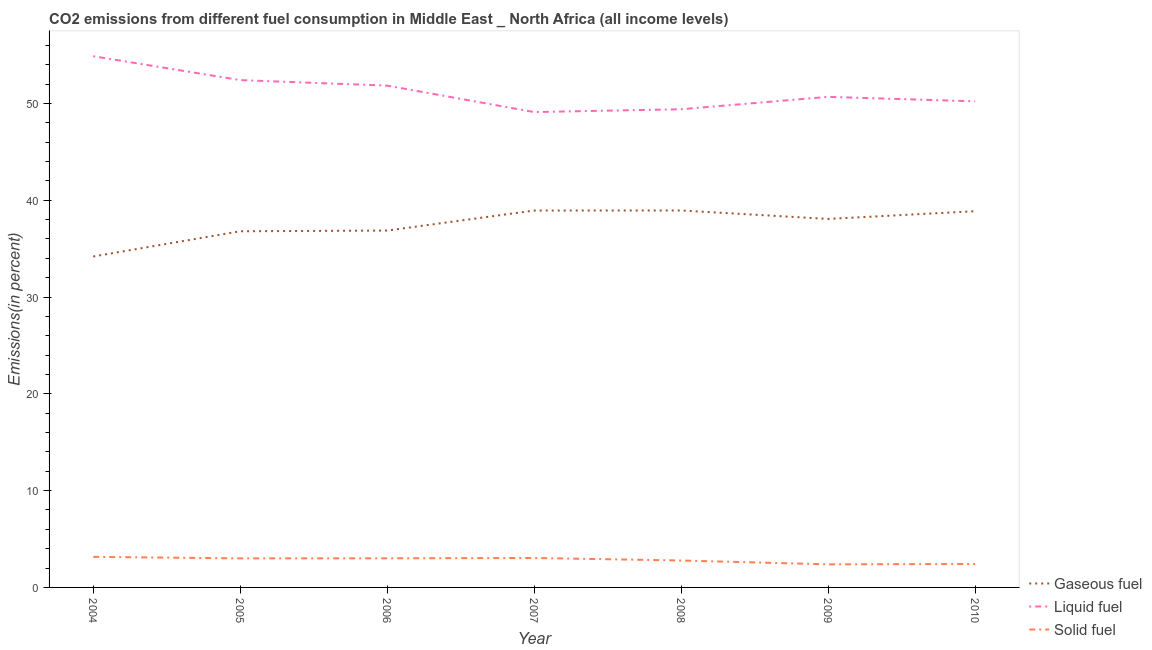What is the percentage of liquid fuel emission in 2008?
Give a very brief answer. 49.4. Across all years, what is the maximum percentage of gaseous fuel emission?
Provide a short and direct response. 38.94. Across all years, what is the minimum percentage of liquid fuel emission?
Your answer should be very brief. 49.11. In which year was the percentage of gaseous fuel emission minimum?
Offer a very short reply. 2004. What is the total percentage of solid fuel emission in the graph?
Offer a terse response. 19.8. What is the difference between the percentage of gaseous fuel emission in 2005 and that in 2010?
Give a very brief answer. -2.07. What is the difference between the percentage of solid fuel emission in 2004 and the percentage of gaseous fuel emission in 2009?
Your answer should be very brief. -34.91. What is the average percentage of solid fuel emission per year?
Your answer should be compact. 2.83. In the year 2005, what is the difference between the percentage of solid fuel emission and percentage of liquid fuel emission?
Your answer should be compact. -49.41. What is the ratio of the percentage of solid fuel emission in 2004 to that in 2010?
Make the answer very short. 1.3. Is the percentage of solid fuel emission in 2007 less than that in 2008?
Provide a succinct answer. No. What is the difference between the highest and the second highest percentage of liquid fuel emission?
Offer a very short reply. 2.47. What is the difference between the highest and the lowest percentage of gaseous fuel emission?
Your answer should be very brief. 4.75. Is the sum of the percentage of liquid fuel emission in 2004 and 2006 greater than the maximum percentage of solid fuel emission across all years?
Offer a terse response. Yes. Is it the case that in every year, the sum of the percentage of gaseous fuel emission and percentage of liquid fuel emission is greater than the percentage of solid fuel emission?
Provide a short and direct response. Yes. How many lines are there?
Make the answer very short. 3. What is the difference between two consecutive major ticks on the Y-axis?
Your response must be concise. 10. Does the graph contain grids?
Make the answer very short. No. What is the title of the graph?
Your answer should be very brief. CO2 emissions from different fuel consumption in Middle East _ North Africa (all income levels). What is the label or title of the X-axis?
Provide a short and direct response. Year. What is the label or title of the Y-axis?
Provide a short and direct response. Emissions(in percent). What is the Emissions(in percent) in Gaseous fuel in 2004?
Give a very brief answer. 34.19. What is the Emissions(in percent) of Liquid fuel in 2004?
Give a very brief answer. 54.88. What is the Emissions(in percent) of Solid fuel in 2004?
Provide a short and direct response. 3.16. What is the Emissions(in percent) in Gaseous fuel in 2005?
Make the answer very short. 36.8. What is the Emissions(in percent) in Liquid fuel in 2005?
Your answer should be compact. 52.41. What is the Emissions(in percent) of Solid fuel in 2005?
Make the answer very short. 3. What is the Emissions(in percent) in Gaseous fuel in 2006?
Make the answer very short. 36.87. What is the Emissions(in percent) of Liquid fuel in 2006?
Ensure brevity in your answer.  51.84. What is the Emissions(in percent) of Solid fuel in 2006?
Keep it short and to the point. 3.01. What is the Emissions(in percent) of Gaseous fuel in 2007?
Your answer should be compact. 38.94. What is the Emissions(in percent) of Liquid fuel in 2007?
Your answer should be very brief. 49.11. What is the Emissions(in percent) of Solid fuel in 2007?
Keep it short and to the point. 3.04. What is the Emissions(in percent) in Gaseous fuel in 2008?
Your answer should be compact. 38.94. What is the Emissions(in percent) in Liquid fuel in 2008?
Your answer should be very brief. 49.4. What is the Emissions(in percent) of Solid fuel in 2008?
Give a very brief answer. 2.78. What is the Emissions(in percent) of Gaseous fuel in 2009?
Your answer should be very brief. 38.07. What is the Emissions(in percent) of Liquid fuel in 2009?
Keep it short and to the point. 50.68. What is the Emissions(in percent) of Solid fuel in 2009?
Provide a short and direct response. 2.38. What is the Emissions(in percent) in Gaseous fuel in 2010?
Keep it short and to the point. 38.87. What is the Emissions(in percent) in Liquid fuel in 2010?
Your answer should be compact. 50.22. What is the Emissions(in percent) in Solid fuel in 2010?
Your response must be concise. 2.42. Across all years, what is the maximum Emissions(in percent) in Gaseous fuel?
Offer a very short reply. 38.94. Across all years, what is the maximum Emissions(in percent) of Liquid fuel?
Provide a short and direct response. 54.88. Across all years, what is the maximum Emissions(in percent) of Solid fuel?
Offer a very short reply. 3.16. Across all years, what is the minimum Emissions(in percent) of Gaseous fuel?
Offer a terse response. 34.19. Across all years, what is the minimum Emissions(in percent) of Liquid fuel?
Give a very brief answer. 49.11. Across all years, what is the minimum Emissions(in percent) in Solid fuel?
Your response must be concise. 2.38. What is the total Emissions(in percent) in Gaseous fuel in the graph?
Your answer should be compact. 262.67. What is the total Emissions(in percent) of Liquid fuel in the graph?
Keep it short and to the point. 358.54. What is the total Emissions(in percent) in Solid fuel in the graph?
Make the answer very short. 19.8. What is the difference between the Emissions(in percent) of Gaseous fuel in 2004 and that in 2005?
Provide a succinct answer. -2.6. What is the difference between the Emissions(in percent) in Liquid fuel in 2004 and that in 2005?
Provide a succinct answer. 2.46. What is the difference between the Emissions(in percent) of Solid fuel in 2004 and that in 2005?
Give a very brief answer. 0.16. What is the difference between the Emissions(in percent) in Gaseous fuel in 2004 and that in 2006?
Provide a succinct answer. -2.68. What is the difference between the Emissions(in percent) in Liquid fuel in 2004 and that in 2006?
Provide a succinct answer. 3.04. What is the difference between the Emissions(in percent) of Solid fuel in 2004 and that in 2006?
Ensure brevity in your answer.  0.15. What is the difference between the Emissions(in percent) in Gaseous fuel in 2004 and that in 2007?
Keep it short and to the point. -4.74. What is the difference between the Emissions(in percent) of Liquid fuel in 2004 and that in 2007?
Your response must be concise. 5.77. What is the difference between the Emissions(in percent) of Solid fuel in 2004 and that in 2007?
Provide a short and direct response. 0.11. What is the difference between the Emissions(in percent) of Gaseous fuel in 2004 and that in 2008?
Ensure brevity in your answer.  -4.75. What is the difference between the Emissions(in percent) of Liquid fuel in 2004 and that in 2008?
Make the answer very short. 5.48. What is the difference between the Emissions(in percent) of Solid fuel in 2004 and that in 2008?
Your answer should be very brief. 0.38. What is the difference between the Emissions(in percent) in Gaseous fuel in 2004 and that in 2009?
Your response must be concise. -3.88. What is the difference between the Emissions(in percent) of Liquid fuel in 2004 and that in 2009?
Your answer should be very brief. 4.2. What is the difference between the Emissions(in percent) in Solid fuel in 2004 and that in 2009?
Make the answer very short. 0.77. What is the difference between the Emissions(in percent) in Gaseous fuel in 2004 and that in 2010?
Offer a terse response. -4.68. What is the difference between the Emissions(in percent) in Liquid fuel in 2004 and that in 2010?
Offer a terse response. 4.66. What is the difference between the Emissions(in percent) of Solid fuel in 2004 and that in 2010?
Offer a terse response. 0.74. What is the difference between the Emissions(in percent) in Gaseous fuel in 2005 and that in 2006?
Your response must be concise. -0.07. What is the difference between the Emissions(in percent) in Liquid fuel in 2005 and that in 2006?
Provide a short and direct response. 0.57. What is the difference between the Emissions(in percent) of Solid fuel in 2005 and that in 2006?
Offer a very short reply. -0.01. What is the difference between the Emissions(in percent) of Gaseous fuel in 2005 and that in 2007?
Your answer should be compact. -2.14. What is the difference between the Emissions(in percent) of Liquid fuel in 2005 and that in 2007?
Provide a succinct answer. 3.3. What is the difference between the Emissions(in percent) of Solid fuel in 2005 and that in 2007?
Your response must be concise. -0.04. What is the difference between the Emissions(in percent) of Gaseous fuel in 2005 and that in 2008?
Keep it short and to the point. -2.15. What is the difference between the Emissions(in percent) of Liquid fuel in 2005 and that in 2008?
Provide a succinct answer. 3.01. What is the difference between the Emissions(in percent) in Solid fuel in 2005 and that in 2008?
Your answer should be compact. 0.22. What is the difference between the Emissions(in percent) of Gaseous fuel in 2005 and that in 2009?
Your answer should be compact. -1.27. What is the difference between the Emissions(in percent) in Liquid fuel in 2005 and that in 2009?
Your response must be concise. 1.73. What is the difference between the Emissions(in percent) in Solid fuel in 2005 and that in 2009?
Offer a terse response. 0.62. What is the difference between the Emissions(in percent) in Gaseous fuel in 2005 and that in 2010?
Offer a very short reply. -2.07. What is the difference between the Emissions(in percent) in Liquid fuel in 2005 and that in 2010?
Ensure brevity in your answer.  2.2. What is the difference between the Emissions(in percent) in Solid fuel in 2005 and that in 2010?
Your answer should be compact. 0.58. What is the difference between the Emissions(in percent) of Gaseous fuel in 2006 and that in 2007?
Your response must be concise. -2.07. What is the difference between the Emissions(in percent) in Liquid fuel in 2006 and that in 2007?
Ensure brevity in your answer.  2.73. What is the difference between the Emissions(in percent) in Solid fuel in 2006 and that in 2007?
Your answer should be compact. -0.04. What is the difference between the Emissions(in percent) of Gaseous fuel in 2006 and that in 2008?
Give a very brief answer. -2.07. What is the difference between the Emissions(in percent) of Liquid fuel in 2006 and that in 2008?
Keep it short and to the point. 2.44. What is the difference between the Emissions(in percent) in Solid fuel in 2006 and that in 2008?
Offer a very short reply. 0.23. What is the difference between the Emissions(in percent) in Gaseous fuel in 2006 and that in 2009?
Provide a succinct answer. -1.2. What is the difference between the Emissions(in percent) in Liquid fuel in 2006 and that in 2009?
Offer a very short reply. 1.16. What is the difference between the Emissions(in percent) of Solid fuel in 2006 and that in 2009?
Your response must be concise. 0.62. What is the difference between the Emissions(in percent) of Gaseous fuel in 2006 and that in 2010?
Give a very brief answer. -2. What is the difference between the Emissions(in percent) in Liquid fuel in 2006 and that in 2010?
Offer a very short reply. 1.62. What is the difference between the Emissions(in percent) in Solid fuel in 2006 and that in 2010?
Your answer should be very brief. 0.59. What is the difference between the Emissions(in percent) in Gaseous fuel in 2007 and that in 2008?
Give a very brief answer. -0.01. What is the difference between the Emissions(in percent) of Liquid fuel in 2007 and that in 2008?
Offer a very short reply. -0.29. What is the difference between the Emissions(in percent) in Solid fuel in 2007 and that in 2008?
Your response must be concise. 0.26. What is the difference between the Emissions(in percent) in Gaseous fuel in 2007 and that in 2009?
Provide a short and direct response. 0.87. What is the difference between the Emissions(in percent) in Liquid fuel in 2007 and that in 2009?
Offer a very short reply. -1.57. What is the difference between the Emissions(in percent) of Solid fuel in 2007 and that in 2009?
Ensure brevity in your answer.  0.66. What is the difference between the Emissions(in percent) of Gaseous fuel in 2007 and that in 2010?
Your answer should be compact. 0.07. What is the difference between the Emissions(in percent) in Liquid fuel in 2007 and that in 2010?
Provide a short and direct response. -1.11. What is the difference between the Emissions(in percent) of Solid fuel in 2007 and that in 2010?
Your answer should be very brief. 0.62. What is the difference between the Emissions(in percent) of Gaseous fuel in 2008 and that in 2009?
Offer a terse response. 0.87. What is the difference between the Emissions(in percent) in Liquid fuel in 2008 and that in 2009?
Ensure brevity in your answer.  -1.28. What is the difference between the Emissions(in percent) in Solid fuel in 2008 and that in 2009?
Give a very brief answer. 0.4. What is the difference between the Emissions(in percent) in Gaseous fuel in 2008 and that in 2010?
Ensure brevity in your answer.  0.07. What is the difference between the Emissions(in percent) in Liquid fuel in 2008 and that in 2010?
Your answer should be very brief. -0.82. What is the difference between the Emissions(in percent) in Solid fuel in 2008 and that in 2010?
Offer a very short reply. 0.36. What is the difference between the Emissions(in percent) in Gaseous fuel in 2009 and that in 2010?
Offer a terse response. -0.8. What is the difference between the Emissions(in percent) in Liquid fuel in 2009 and that in 2010?
Provide a succinct answer. 0.46. What is the difference between the Emissions(in percent) in Solid fuel in 2009 and that in 2010?
Offer a terse response. -0.04. What is the difference between the Emissions(in percent) of Gaseous fuel in 2004 and the Emissions(in percent) of Liquid fuel in 2005?
Keep it short and to the point. -18.22. What is the difference between the Emissions(in percent) of Gaseous fuel in 2004 and the Emissions(in percent) of Solid fuel in 2005?
Offer a very short reply. 31.19. What is the difference between the Emissions(in percent) of Liquid fuel in 2004 and the Emissions(in percent) of Solid fuel in 2005?
Keep it short and to the point. 51.88. What is the difference between the Emissions(in percent) in Gaseous fuel in 2004 and the Emissions(in percent) in Liquid fuel in 2006?
Your answer should be compact. -17.65. What is the difference between the Emissions(in percent) in Gaseous fuel in 2004 and the Emissions(in percent) in Solid fuel in 2006?
Give a very brief answer. 31.18. What is the difference between the Emissions(in percent) in Liquid fuel in 2004 and the Emissions(in percent) in Solid fuel in 2006?
Your response must be concise. 51.87. What is the difference between the Emissions(in percent) of Gaseous fuel in 2004 and the Emissions(in percent) of Liquid fuel in 2007?
Ensure brevity in your answer.  -14.92. What is the difference between the Emissions(in percent) in Gaseous fuel in 2004 and the Emissions(in percent) in Solid fuel in 2007?
Offer a terse response. 31.15. What is the difference between the Emissions(in percent) of Liquid fuel in 2004 and the Emissions(in percent) of Solid fuel in 2007?
Offer a very short reply. 51.83. What is the difference between the Emissions(in percent) of Gaseous fuel in 2004 and the Emissions(in percent) of Liquid fuel in 2008?
Offer a very short reply. -15.21. What is the difference between the Emissions(in percent) in Gaseous fuel in 2004 and the Emissions(in percent) in Solid fuel in 2008?
Keep it short and to the point. 31.41. What is the difference between the Emissions(in percent) in Liquid fuel in 2004 and the Emissions(in percent) in Solid fuel in 2008?
Ensure brevity in your answer.  52.1. What is the difference between the Emissions(in percent) of Gaseous fuel in 2004 and the Emissions(in percent) of Liquid fuel in 2009?
Provide a succinct answer. -16.49. What is the difference between the Emissions(in percent) of Gaseous fuel in 2004 and the Emissions(in percent) of Solid fuel in 2009?
Your answer should be very brief. 31.81. What is the difference between the Emissions(in percent) in Liquid fuel in 2004 and the Emissions(in percent) in Solid fuel in 2009?
Your answer should be very brief. 52.49. What is the difference between the Emissions(in percent) in Gaseous fuel in 2004 and the Emissions(in percent) in Liquid fuel in 2010?
Make the answer very short. -16.03. What is the difference between the Emissions(in percent) in Gaseous fuel in 2004 and the Emissions(in percent) in Solid fuel in 2010?
Offer a terse response. 31.77. What is the difference between the Emissions(in percent) of Liquid fuel in 2004 and the Emissions(in percent) of Solid fuel in 2010?
Offer a terse response. 52.46. What is the difference between the Emissions(in percent) of Gaseous fuel in 2005 and the Emissions(in percent) of Liquid fuel in 2006?
Offer a terse response. -15.04. What is the difference between the Emissions(in percent) in Gaseous fuel in 2005 and the Emissions(in percent) in Solid fuel in 2006?
Make the answer very short. 33.79. What is the difference between the Emissions(in percent) of Liquid fuel in 2005 and the Emissions(in percent) of Solid fuel in 2006?
Your answer should be compact. 49.4. What is the difference between the Emissions(in percent) of Gaseous fuel in 2005 and the Emissions(in percent) of Liquid fuel in 2007?
Provide a succinct answer. -12.31. What is the difference between the Emissions(in percent) of Gaseous fuel in 2005 and the Emissions(in percent) of Solid fuel in 2007?
Your response must be concise. 33.75. What is the difference between the Emissions(in percent) of Liquid fuel in 2005 and the Emissions(in percent) of Solid fuel in 2007?
Ensure brevity in your answer.  49.37. What is the difference between the Emissions(in percent) in Gaseous fuel in 2005 and the Emissions(in percent) in Liquid fuel in 2008?
Your answer should be compact. -12.6. What is the difference between the Emissions(in percent) of Gaseous fuel in 2005 and the Emissions(in percent) of Solid fuel in 2008?
Your answer should be very brief. 34.01. What is the difference between the Emissions(in percent) in Liquid fuel in 2005 and the Emissions(in percent) in Solid fuel in 2008?
Give a very brief answer. 49.63. What is the difference between the Emissions(in percent) in Gaseous fuel in 2005 and the Emissions(in percent) in Liquid fuel in 2009?
Your response must be concise. -13.89. What is the difference between the Emissions(in percent) in Gaseous fuel in 2005 and the Emissions(in percent) in Solid fuel in 2009?
Offer a terse response. 34.41. What is the difference between the Emissions(in percent) of Liquid fuel in 2005 and the Emissions(in percent) of Solid fuel in 2009?
Offer a very short reply. 50.03. What is the difference between the Emissions(in percent) of Gaseous fuel in 2005 and the Emissions(in percent) of Liquid fuel in 2010?
Ensure brevity in your answer.  -13.42. What is the difference between the Emissions(in percent) of Gaseous fuel in 2005 and the Emissions(in percent) of Solid fuel in 2010?
Your answer should be very brief. 34.37. What is the difference between the Emissions(in percent) in Liquid fuel in 2005 and the Emissions(in percent) in Solid fuel in 2010?
Your answer should be compact. 49.99. What is the difference between the Emissions(in percent) in Gaseous fuel in 2006 and the Emissions(in percent) in Liquid fuel in 2007?
Provide a succinct answer. -12.24. What is the difference between the Emissions(in percent) in Gaseous fuel in 2006 and the Emissions(in percent) in Solid fuel in 2007?
Your response must be concise. 33.82. What is the difference between the Emissions(in percent) in Liquid fuel in 2006 and the Emissions(in percent) in Solid fuel in 2007?
Ensure brevity in your answer.  48.8. What is the difference between the Emissions(in percent) of Gaseous fuel in 2006 and the Emissions(in percent) of Liquid fuel in 2008?
Ensure brevity in your answer.  -12.53. What is the difference between the Emissions(in percent) in Gaseous fuel in 2006 and the Emissions(in percent) in Solid fuel in 2008?
Your response must be concise. 34.09. What is the difference between the Emissions(in percent) in Liquid fuel in 2006 and the Emissions(in percent) in Solid fuel in 2008?
Your answer should be very brief. 49.06. What is the difference between the Emissions(in percent) of Gaseous fuel in 2006 and the Emissions(in percent) of Liquid fuel in 2009?
Offer a very short reply. -13.81. What is the difference between the Emissions(in percent) in Gaseous fuel in 2006 and the Emissions(in percent) in Solid fuel in 2009?
Offer a terse response. 34.48. What is the difference between the Emissions(in percent) of Liquid fuel in 2006 and the Emissions(in percent) of Solid fuel in 2009?
Make the answer very short. 49.46. What is the difference between the Emissions(in percent) of Gaseous fuel in 2006 and the Emissions(in percent) of Liquid fuel in 2010?
Your answer should be very brief. -13.35. What is the difference between the Emissions(in percent) in Gaseous fuel in 2006 and the Emissions(in percent) in Solid fuel in 2010?
Your response must be concise. 34.45. What is the difference between the Emissions(in percent) in Liquid fuel in 2006 and the Emissions(in percent) in Solid fuel in 2010?
Offer a very short reply. 49.42. What is the difference between the Emissions(in percent) of Gaseous fuel in 2007 and the Emissions(in percent) of Liquid fuel in 2008?
Provide a succinct answer. -10.46. What is the difference between the Emissions(in percent) in Gaseous fuel in 2007 and the Emissions(in percent) in Solid fuel in 2008?
Your answer should be compact. 36.15. What is the difference between the Emissions(in percent) of Liquid fuel in 2007 and the Emissions(in percent) of Solid fuel in 2008?
Keep it short and to the point. 46.33. What is the difference between the Emissions(in percent) in Gaseous fuel in 2007 and the Emissions(in percent) in Liquid fuel in 2009?
Your answer should be compact. -11.75. What is the difference between the Emissions(in percent) of Gaseous fuel in 2007 and the Emissions(in percent) of Solid fuel in 2009?
Provide a short and direct response. 36.55. What is the difference between the Emissions(in percent) in Liquid fuel in 2007 and the Emissions(in percent) in Solid fuel in 2009?
Offer a very short reply. 46.73. What is the difference between the Emissions(in percent) in Gaseous fuel in 2007 and the Emissions(in percent) in Liquid fuel in 2010?
Your response must be concise. -11.28. What is the difference between the Emissions(in percent) in Gaseous fuel in 2007 and the Emissions(in percent) in Solid fuel in 2010?
Make the answer very short. 36.51. What is the difference between the Emissions(in percent) in Liquid fuel in 2007 and the Emissions(in percent) in Solid fuel in 2010?
Offer a terse response. 46.69. What is the difference between the Emissions(in percent) in Gaseous fuel in 2008 and the Emissions(in percent) in Liquid fuel in 2009?
Provide a succinct answer. -11.74. What is the difference between the Emissions(in percent) of Gaseous fuel in 2008 and the Emissions(in percent) of Solid fuel in 2009?
Keep it short and to the point. 36.56. What is the difference between the Emissions(in percent) in Liquid fuel in 2008 and the Emissions(in percent) in Solid fuel in 2009?
Provide a succinct answer. 47.02. What is the difference between the Emissions(in percent) in Gaseous fuel in 2008 and the Emissions(in percent) in Liquid fuel in 2010?
Your answer should be very brief. -11.28. What is the difference between the Emissions(in percent) of Gaseous fuel in 2008 and the Emissions(in percent) of Solid fuel in 2010?
Provide a succinct answer. 36.52. What is the difference between the Emissions(in percent) in Liquid fuel in 2008 and the Emissions(in percent) in Solid fuel in 2010?
Your answer should be very brief. 46.98. What is the difference between the Emissions(in percent) in Gaseous fuel in 2009 and the Emissions(in percent) in Liquid fuel in 2010?
Keep it short and to the point. -12.15. What is the difference between the Emissions(in percent) of Gaseous fuel in 2009 and the Emissions(in percent) of Solid fuel in 2010?
Your answer should be compact. 35.65. What is the difference between the Emissions(in percent) of Liquid fuel in 2009 and the Emissions(in percent) of Solid fuel in 2010?
Offer a very short reply. 48.26. What is the average Emissions(in percent) in Gaseous fuel per year?
Your response must be concise. 37.52. What is the average Emissions(in percent) in Liquid fuel per year?
Provide a short and direct response. 51.22. What is the average Emissions(in percent) in Solid fuel per year?
Provide a short and direct response. 2.83. In the year 2004, what is the difference between the Emissions(in percent) of Gaseous fuel and Emissions(in percent) of Liquid fuel?
Offer a very short reply. -20.69. In the year 2004, what is the difference between the Emissions(in percent) in Gaseous fuel and Emissions(in percent) in Solid fuel?
Your answer should be very brief. 31.03. In the year 2004, what is the difference between the Emissions(in percent) of Liquid fuel and Emissions(in percent) of Solid fuel?
Offer a terse response. 51.72. In the year 2005, what is the difference between the Emissions(in percent) in Gaseous fuel and Emissions(in percent) in Liquid fuel?
Your answer should be very brief. -15.62. In the year 2005, what is the difference between the Emissions(in percent) of Gaseous fuel and Emissions(in percent) of Solid fuel?
Give a very brief answer. 33.8. In the year 2005, what is the difference between the Emissions(in percent) of Liquid fuel and Emissions(in percent) of Solid fuel?
Your response must be concise. 49.41. In the year 2006, what is the difference between the Emissions(in percent) of Gaseous fuel and Emissions(in percent) of Liquid fuel?
Your answer should be very brief. -14.97. In the year 2006, what is the difference between the Emissions(in percent) in Gaseous fuel and Emissions(in percent) in Solid fuel?
Your response must be concise. 33.86. In the year 2006, what is the difference between the Emissions(in percent) of Liquid fuel and Emissions(in percent) of Solid fuel?
Give a very brief answer. 48.83. In the year 2007, what is the difference between the Emissions(in percent) of Gaseous fuel and Emissions(in percent) of Liquid fuel?
Make the answer very short. -10.17. In the year 2007, what is the difference between the Emissions(in percent) in Gaseous fuel and Emissions(in percent) in Solid fuel?
Keep it short and to the point. 35.89. In the year 2007, what is the difference between the Emissions(in percent) in Liquid fuel and Emissions(in percent) in Solid fuel?
Your answer should be very brief. 46.07. In the year 2008, what is the difference between the Emissions(in percent) in Gaseous fuel and Emissions(in percent) in Liquid fuel?
Make the answer very short. -10.46. In the year 2008, what is the difference between the Emissions(in percent) in Gaseous fuel and Emissions(in percent) in Solid fuel?
Offer a very short reply. 36.16. In the year 2008, what is the difference between the Emissions(in percent) of Liquid fuel and Emissions(in percent) of Solid fuel?
Your answer should be very brief. 46.62. In the year 2009, what is the difference between the Emissions(in percent) in Gaseous fuel and Emissions(in percent) in Liquid fuel?
Your response must be concise. -12.61. In the year 2009, what is the difference between the Emissions(in percent) of Gaseous fuel and Emissions(in percent) of Solid fuel?
Offer a very short reply. 35.68. In the year 2009, what is the difference between the Emissions(in percent) of Liquid fuel and Emissions(in percent) of Solid fuel?
Your response must be concise. 48.3. In the year 2010, what is the difference between the Emissions(in percent) of Gaseous fuel and Emissions(in percent) of Liquid fuel?
Keep it short and to the point. -11.35. In the year 2010, what is the difference between the Emissions(in percent) in Gaseous fuel and Emissions(in percent) in Solid fuel?
Make the answer very short. 36.45. In the year 2010, what is the difference between the Emissions(in percent) in Liquid fuel and Emissions(in percent) in Solid fuel?
Offer a very short reply. 47.8. What is the ratio of the Emissions(in percent) in Gaseous fuel in 2004 to that in 2005?
Keep it short and to the point. 0.93. What is the ratio of the Emissions(in percent) of Liquid fuel in 2004 to that in 2005?
Your answer should be very brief. 1.05. What is the ratio of the Emissions(in percent) in Solid fuel in 2004 to that in 2005?
Provide a short and direct response. 1.05. What is the ratio of the Emissions(in percent) in Gaseous fuel in 2004 to that in 2006?
Offer a terse response. 0.93. What is the ratio of the Emissions(in percent) in Liquid fuel in 2004 to that in 2006?
Ensure brevity in your answer.  1.06. What is the ratio of the Emissions(in percent) in Solid fuel in 2004 to that in 2006?
Your response must be concise. 1.05. What is the ratio of the Emissions(in percent) of Gaseous fuel in 2004 to that in 2007?
Make the answer very short. 0.88. What is the ratio of the Emissions(in percent) of Liquid fuel in 2004 to that in 2007?
Your answer should be compact. 1.12. What is the ratio of the Emissions(in percent) of Solid fuel in 2004 to that in 2007?
Offer a very short reply. 1.04. What is the ratio of the Emissions(in percent) of Gaseous fuel in 2004 to that in 2008?
Offer a very short reply. 0.88. What is the ratio of the Emissions(in percent) of Liquid fuel in 2004 to that in 2008?
Ensure brevity in your answer.  1.11. What is the ratio of the Emissions(in percent) of Solid fuel in 2004 to that in 2008?
Make the answer very short. 1.14. What is the ratio of the Emissions(in percent) in Gaseous fuel in 2004 to that in 2009?
Your answer should be very brief. 0.9. What is the ratio of the Emissions(in percent) of Liquid fuel in 2004 to that in 2009?
Your answer should be compact. 1.08. What is the ratio of the Emissions(in percent) of Solid fuel in 2004 to that in 2009?
Offer a very short reply. 1.32. What is the ratio of the Emissions(in percent) of Gaseous fuel in 2004 to that in 2010?
Keep it short and to the point. 0.88. What is the ratio of the Emissions(in percent) of Liquid fuel in 2004 to that in 2010?
Offer a terse response. 1.09. What is the ratio of the Emissions(in percent) of Solid fuel in 2004 to that in 2010?
Your response must be concise. 1.3. What is the ratio of the Emissions(in percent) in Solid fuel in 2005 to that in 2006?
Your response must be concise. 1. What is the ratio of the Emissions(in percent) in Gaseous fuel in 2005 to that in 2007?
Give a very brief answer. 0.94. What is the ratio of the Emissions(in percent) of Liquid fuel in 2005 to that in 2007?
Provide a succinct answer. 1.07. What is the ratio of the Emissions(in percent) in Solid fuel in 2005 to that in 2007?
Give a very brief answer. 0.99. What is the ratio of the Emissions(in percent) in Gaseous fuel in 2005 to that in 2008?
Ensure brevity in your answer.  0.94. What is the ratio of the Emissions(in percent) of Liquid fuel in 2005 to that in 2008?
Provide a short and direct response. 1.06. What is the ratio of the Emissions(in percent) in Solid fuel in 2005 to that in 2008?
Keep it short and to the point. 1.08. What is the ratio of the Emissions(in percent) of Gaseous fuel in 2005 to that in 2009?
Ensure brevity in your answer.  0.97. What is the ratio of the Emissions(in percent) in Liquid fuel in 2005 to that in 2009?
Make the answer very short. 1.03. What is the ratio of the Emissions(in percent) of Solid fuel in 2005 to that in 2009?
Your answer should be compact. 1.26. What is the ratio of the Emissions(in percent) of Gaseous fuel in 2005 to that in 2010?
Your answer should be compact. 0.95. What is the ratio of the Emissions(in percent) of Liquid fuel in 2005 to that in 2010?
Give a very brief answer. 1.04. What is the ratio of the Emissions(in percent) of Solid fuel in 2005 to that in 2010?
Offer a very short reply. 1.24. What is the ratio of the Emissions(in percent) of Gaseous fuel in 2006 to that in 2007?
Your response must be concise. 0.95. What is the ratio of the Emissions(in percent) of Liquid fuel in 2006 to that in 2007?
Provide a short and direct response. 1.06. What is the ratio of the Emissions(in percent) in Solid fuel in 2006 to that in 2007?
Ensure brevity in your answer.  0.99. What is the ratio of the Emissions(in percent) in Gaseous fuel in 2006 to that in 2008?
Ensure brevity in your answer.  0.95. What is the ratio of the Emissions(in percent) of Liquid fuel in 2006 to that in 2008?
Give a very brief answer. 1.05. What is the ratio of the Emissions(in percent) in Solid fuel in 2006 to that in 2008?
Your answer should be compact. 1.08. What is the ratio of the Emissions(in percent) of Gaseous fuel in 2006 to that in 2009?
Offer a terse response. 0.97. What is the ratio of the Emissions(in percent) of Liquid fuel in 2006 to that in 2009?
Offer a very short reply. 1.02. What is the ratio of the Emissions(in percent) of Solid fuel in 2006 to that in 2009?
Offer a terse response. 1.26. What is the ratio of the Emissions(in percent) in Gaseous fuel in 2006 to that in 2010?
Offer a terse response. 0.95. What is the ratio of the Emissions(in percent) of Liquid fuel in 2006 to that in 2010?
Ensure brevity in your answer.  1.03. What is the ratio of the Emissions(in percent) in Solid fuel in 2006 to that in 2010?
Your answer should be very brief. 1.24. What is the ratio of the Emissions(in percent) in Liquid fuel in 2007 to that in 2008?
Provide a short and direct response. 0.99. What is the ratio of the Emissions(in percent) in Solid fuel in 2007 to that in 2008?
Keep it short and to the point. 1.09. What is the ratio of the Emissions(in percent) in Gaseous fuel in 2007 to that in 2009?
Your response must be concise. 1.02. What is the ratio of the Emissions(in percent) of Solid fuel in 2007 to that in 2009?
Give a very brief answer. 1.28. What is the ratio of the Emissions(in percent) of Liquid fuel in 2007 to that in 2010?
Offer a terse response. 0.98. What is the ratio of the Emissions(in percent) in Solid fuel in 2007 to that in 2010?
Your answer should be compact. 1.26. What is the ratio of the Emissions(in percent) of Gaseous fuel in 2008 to that in 2009?
Your answer should be compact. 1.02. What is the ratio of the Emissions(in percent) in Liquid fuel in 2008 to that in 2009?
Your response must be concise. 0.97. What is the ratio of the Emissions(in percent) in Solid fuel in 2008 to that in 2009?
Your answer should be very brief. 1.17. What is the ratio of the Emissions(in percent) of Liquid fuel in 2008 to that in 2010?
Your answer should be very brief. 0.98. What is the ratio of the Emissions(in percent) of Solid fuel in 2008 to that in 2010?
Provide a succinct answer. 1.15. What is the ratio of the Emissions(in percent) of Gaseous fuel in 2009 to that in 2010?
Provide a succinct answer. 0.98. What is the ratio of the Emissions(in percent) in Liquid fuel in 2009 to that in 2010?
Make the answer very short. 1.01. What is the ratio of the Emissions(in percent) in Solid fuel in 2009 to that in 2010?
Give a very brief answer. 0.98. What is the difference between the highest and the second highest Emissions(in percent) in Gaseous fuel?
Make the answer very short. 0.01. What is the difference between the highest and the second highest Emissions(in percent) of Liquid fuel?
Your answer should be compact. 2.46. What is the difference between the highest and the second highest Emissions(in percent) in Solid fuel?
Make the answer very short. 0.11. What is the difference between the highest and the lowest Emissions(in percent) in Gaseous fuel?
Provide a succinct answer. 4.75. What is the difference between the highest and the lowest Emissions(in percent) in Liquid fuel?
Keep it short and to the point. 5.77. What is the difference between the highest and the lowest Emissions(in percent) in Solid fuel?
Make the answer very short. 0.77. 